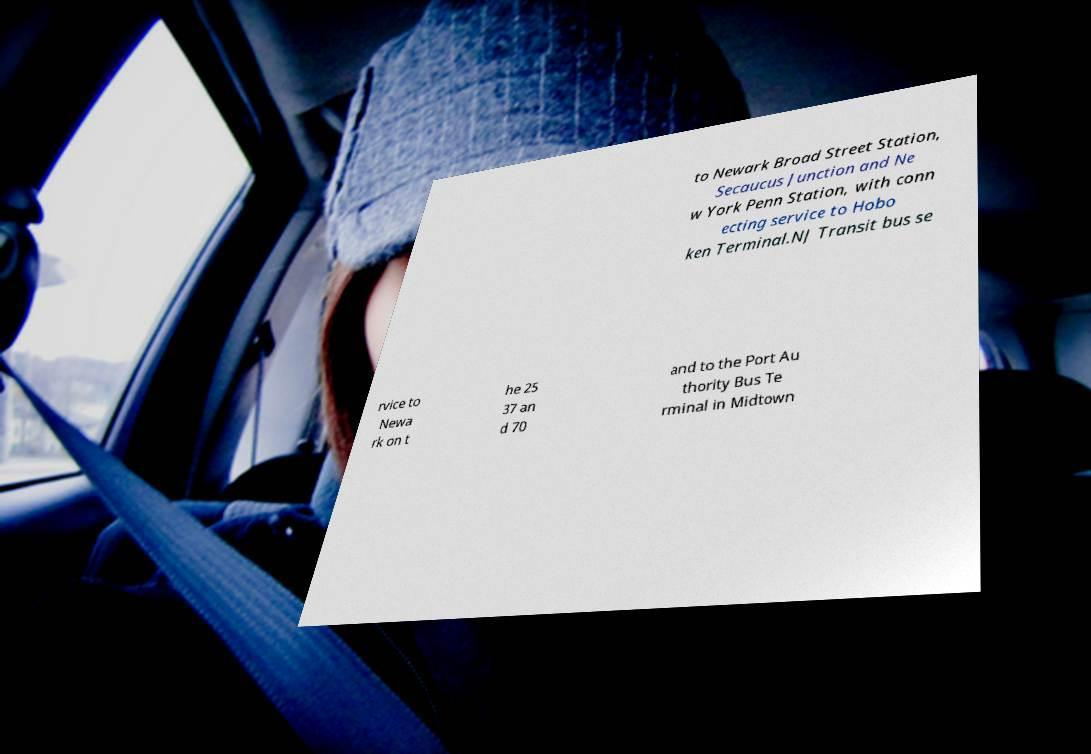What messages or text are displayed in this image? I need them in a readable, typed format. to Newark Broad Street Station, Secaucus Junction and Ne w York Penn Station, with conn ecting service to Hobo ken Terminal.NJ Transit bus se rvice to Newa rk on t he 25 37 an d 70 and to the Port Au thority Bus Te rminal in Midtown 